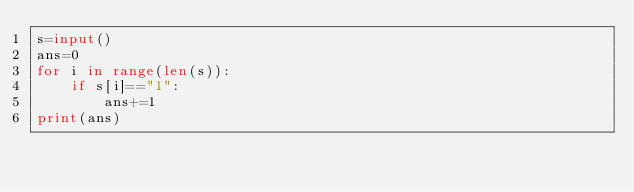<code> <loc_0><loc_0><loc_500><loc_500><_Python_>s=input()
ans=0
for i in range(len(s)):
    if s[i]=="1":
        ans+=1
print(ans)</code> 